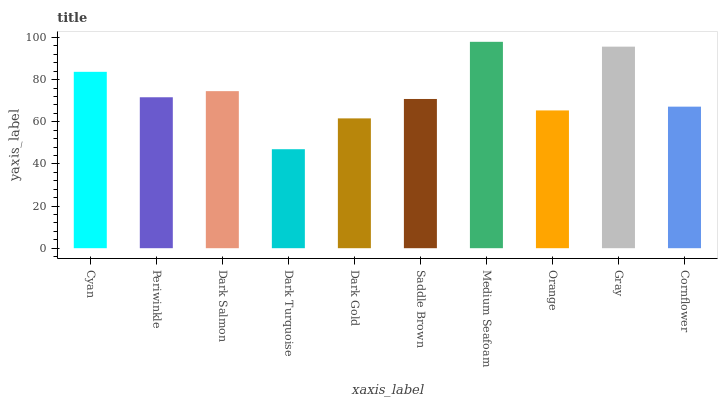Is Dark Turquoise the minimum?
Answer yes or no. Yes. Is Medium Seafoam the maximum?
Answer yes or no. Yes. Is Periwinkle the minimum?
Answer yes or no. No. Is Periwinkle the maximum?
Answer yes or no. No. Is Cyan greater than Periwinkle?
Answer yes or no. Yes. Is Periwinkle less than Cyan?
Answer yes or no. Yes. Is Periwinkle greater than Cyan?
Answer yes or no. No. Is Cyan less than Periwinkle?
Answer yes or no. No. Is Periwinkle the high median?
Answer yes or no. Yes. Is Saddle Brown the low median?
Answer yes or no. Yes. Is Orange the high median?
Answer yes or no. No. Is Cornflower the low median?
Answer yes or no. No. 